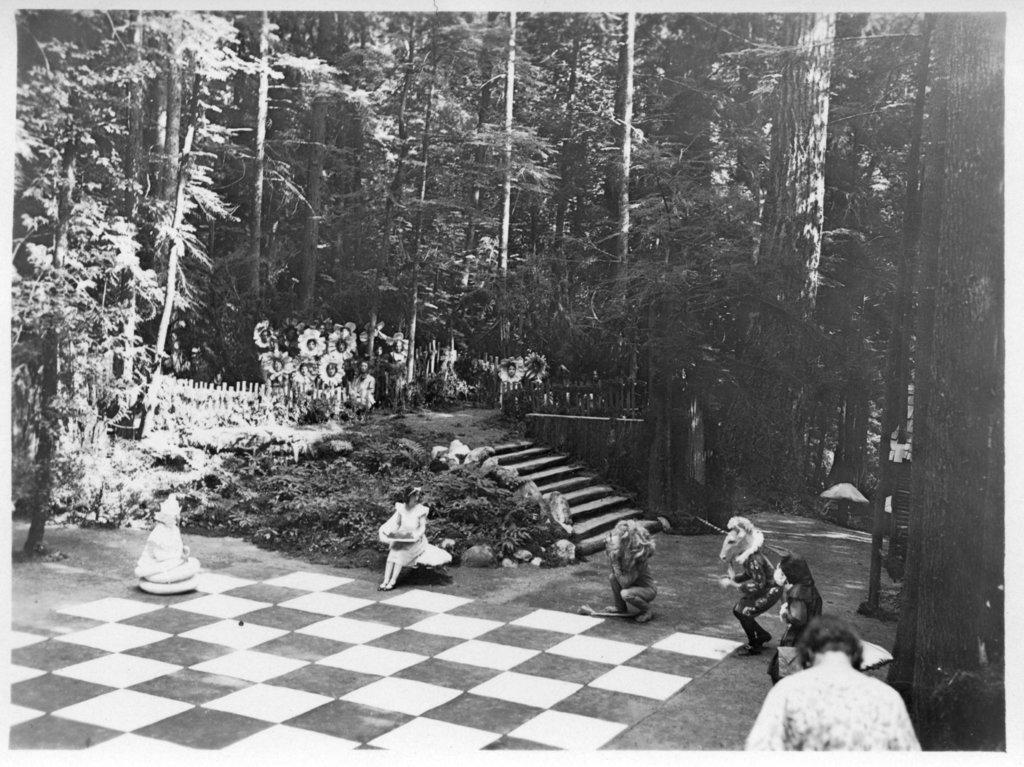Who or what can be seen in the image? There are people in the image. What type of natural elements are present in the image? There are trees in the image. What is the color scheme of the image? The image is in black and white. What type of comb is being used by the people in the image? There is no comb visible in the image. How many cushions are present in the image? There is no mention of cushions in the provided facts, so we cannot determine their presence or quantity in the image. 